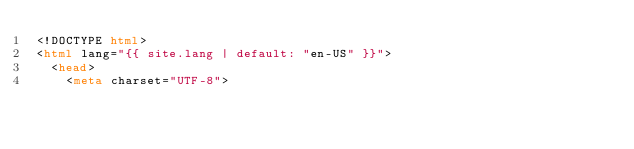<code> <loc_0><loc_0><loc_500><loc_500><_HTML_><!DOCTYPE html>
<html lang="{{ site.lang | default: "en-US" }}">
  <head>
    <meta charset="UTF-8"></code> 